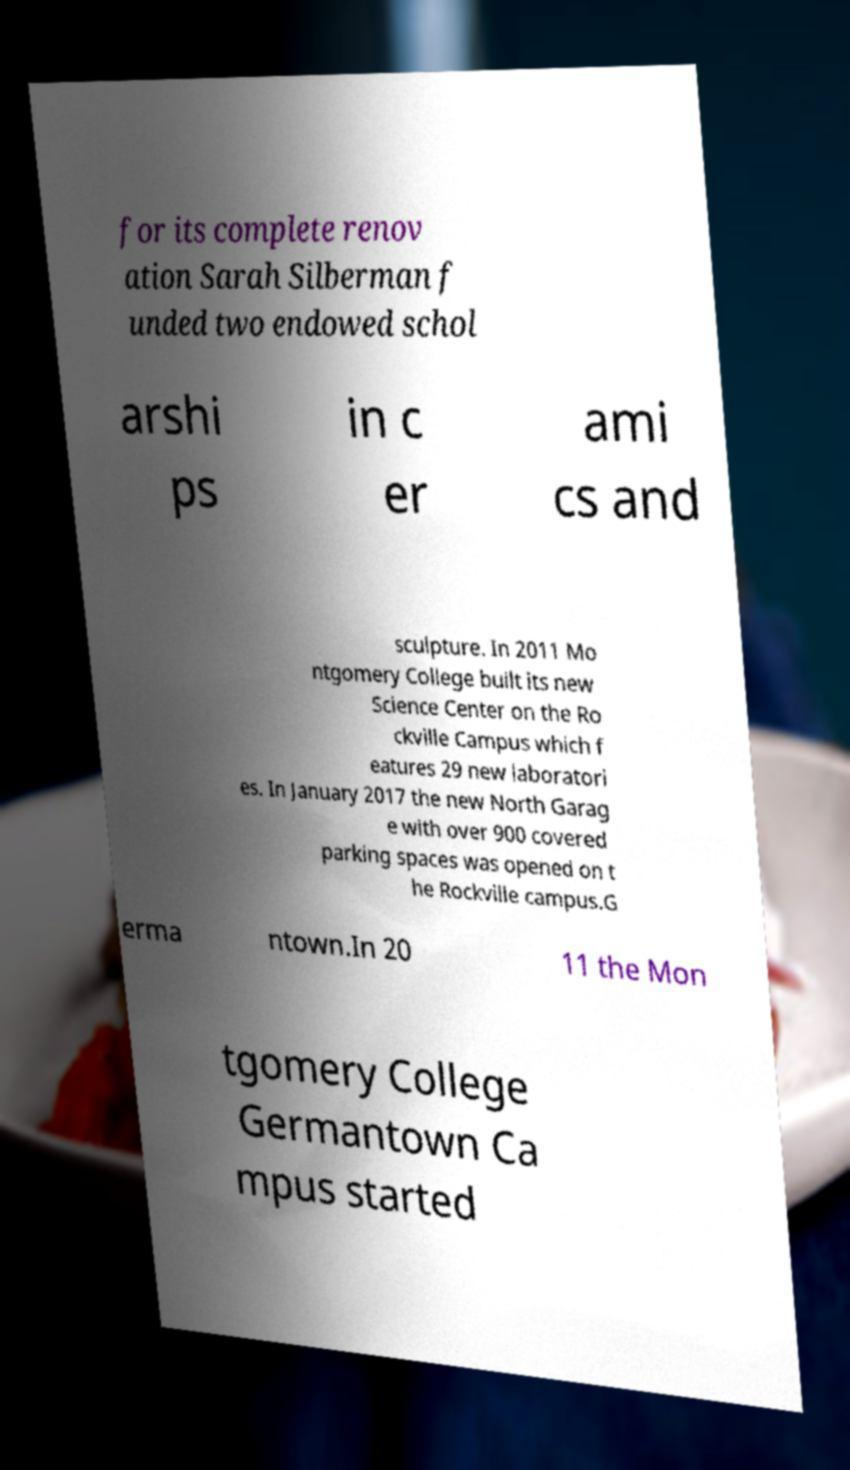Could you extract and type out the text from this image? for its complete renov ation Sarah Silberman f unded two endowed schol arshi ps in c er ami cs and sculpture. In 2011 Mo ntgomery College built its new Science Center on the Ro ckville Campus which f eatures 29 new laboratori es. In January 2017 the new North Garag e with over 900 covered parking spaces was opened on t he Rockville campus.G erma ntown.In 20 11 the Mon tgomery College Germantown Ca mpus started 